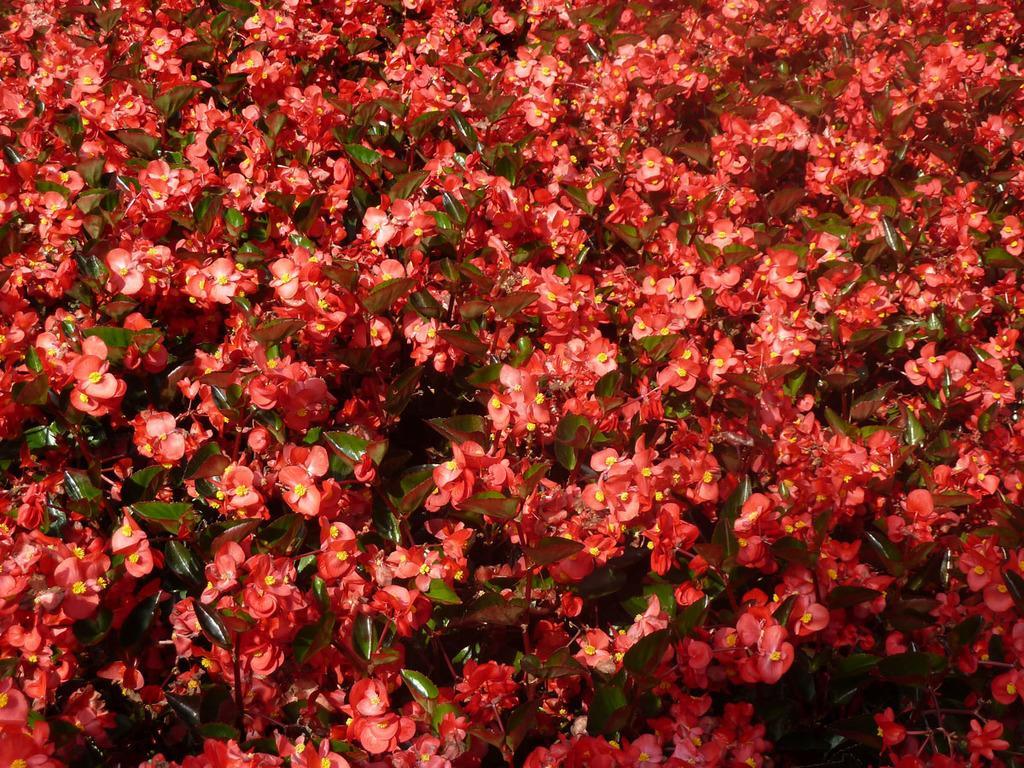In one or two sentences, can you explain what this image depicts? In the image we can see the flowers and the leaves. 